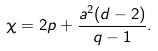<formula> <loc_0><loc_0><loc_500><loc_500>\chi = 2 p + \frac { a ^ { 2 } ( d - 2 ) } { q - 1 } .</formula> 